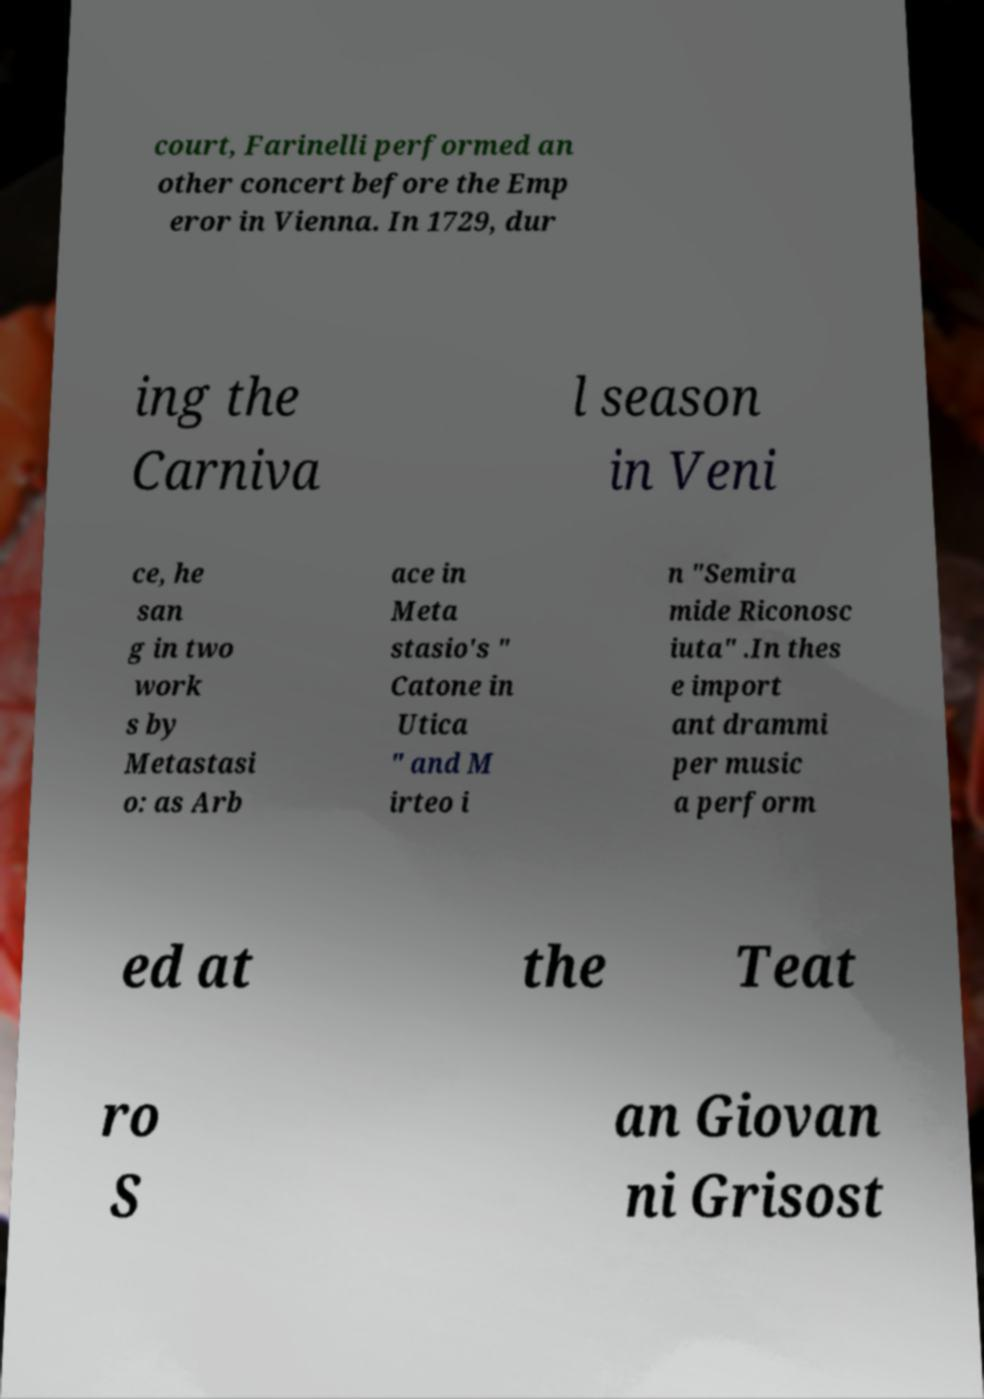Please read and relay the text visible in this image. What does it say? court, Farinelli performed an other concert before the Emp eror in Vienna. In 1729, dur ing the Carniva l season in Veni ce, he san g in two work s by Metastasi o: as Arb ace in Meta stasio's " Catone in Utica " and M irteo i n "Semira mide Riconosc iuta" .In thes e import ant drammi per music a perform ed at the Teat ro S an Giovan ni Grisost 